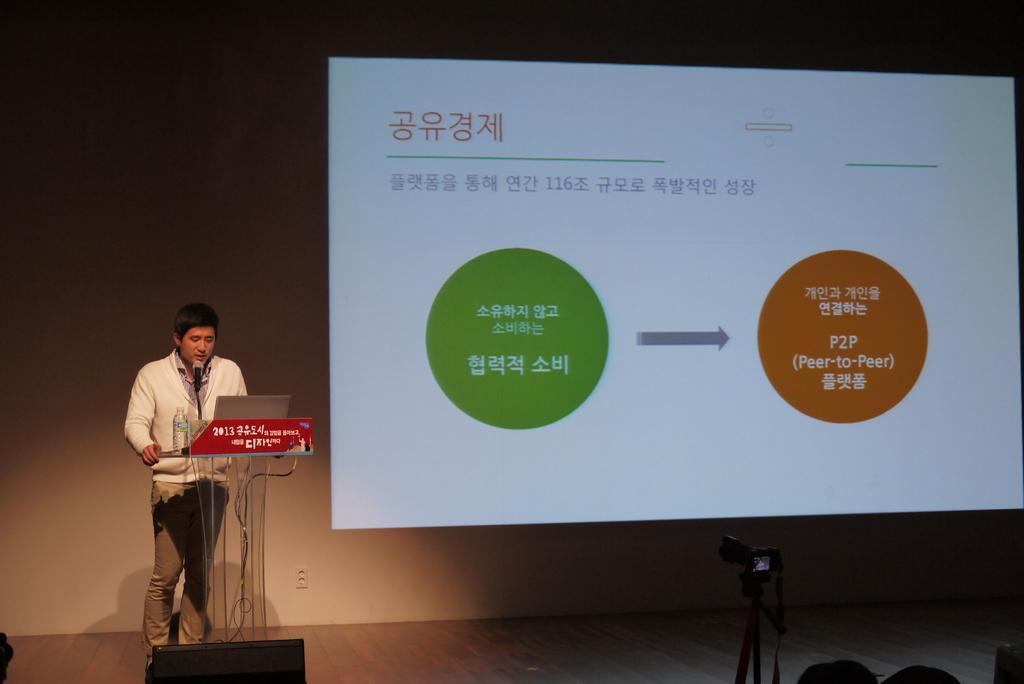Please provide a concise description of this image. In this image we can see a person standing on the floor and a lectern is placed in front of him. On the lectern there are laptop, disposal bottle and a mic attached to it. In the background we can see a display screen. 